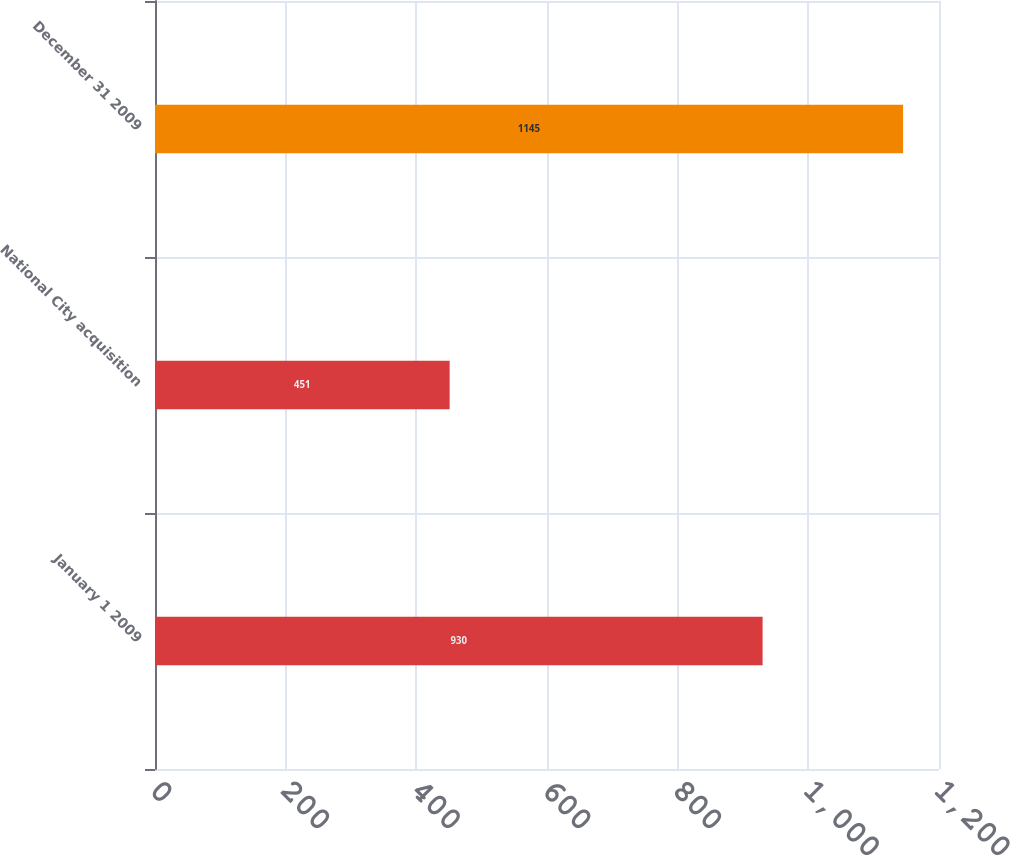<chart> <loc_0><loc_0><loc_500><loc_500><bar_chart><fcel>January 1 2009<fcel>National City acquisition<fcel>December 31 2009<nl><fcel>930<fcel>451<fcel>1145<nl></chart> 